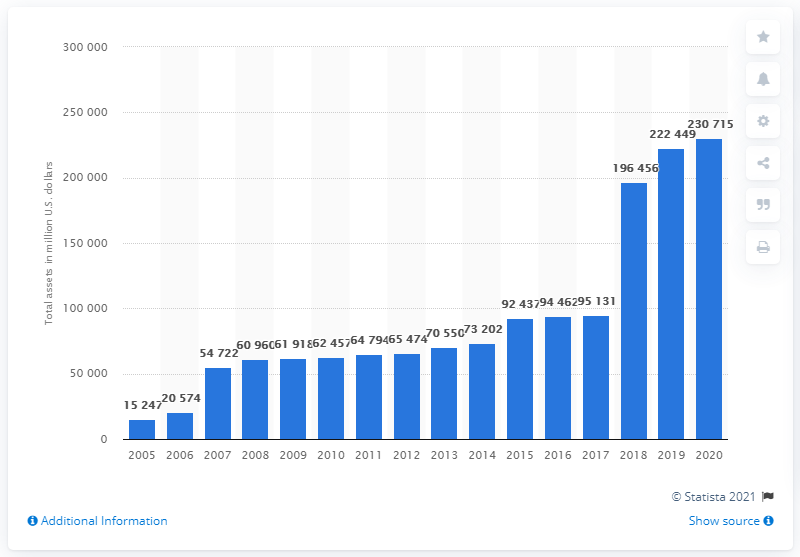Give some essential details in this illustration. The total assets of CVS Health Corporation in dollars from 2005 to 2020 were 230,715. In 2014, CVS changed its name from CVS Caremark to CVS Health. The total assets of CVS Health Corporation in 2020 were approximately 230,715. In 2019, the total assets of CVS Health Corporation were $222,449. 